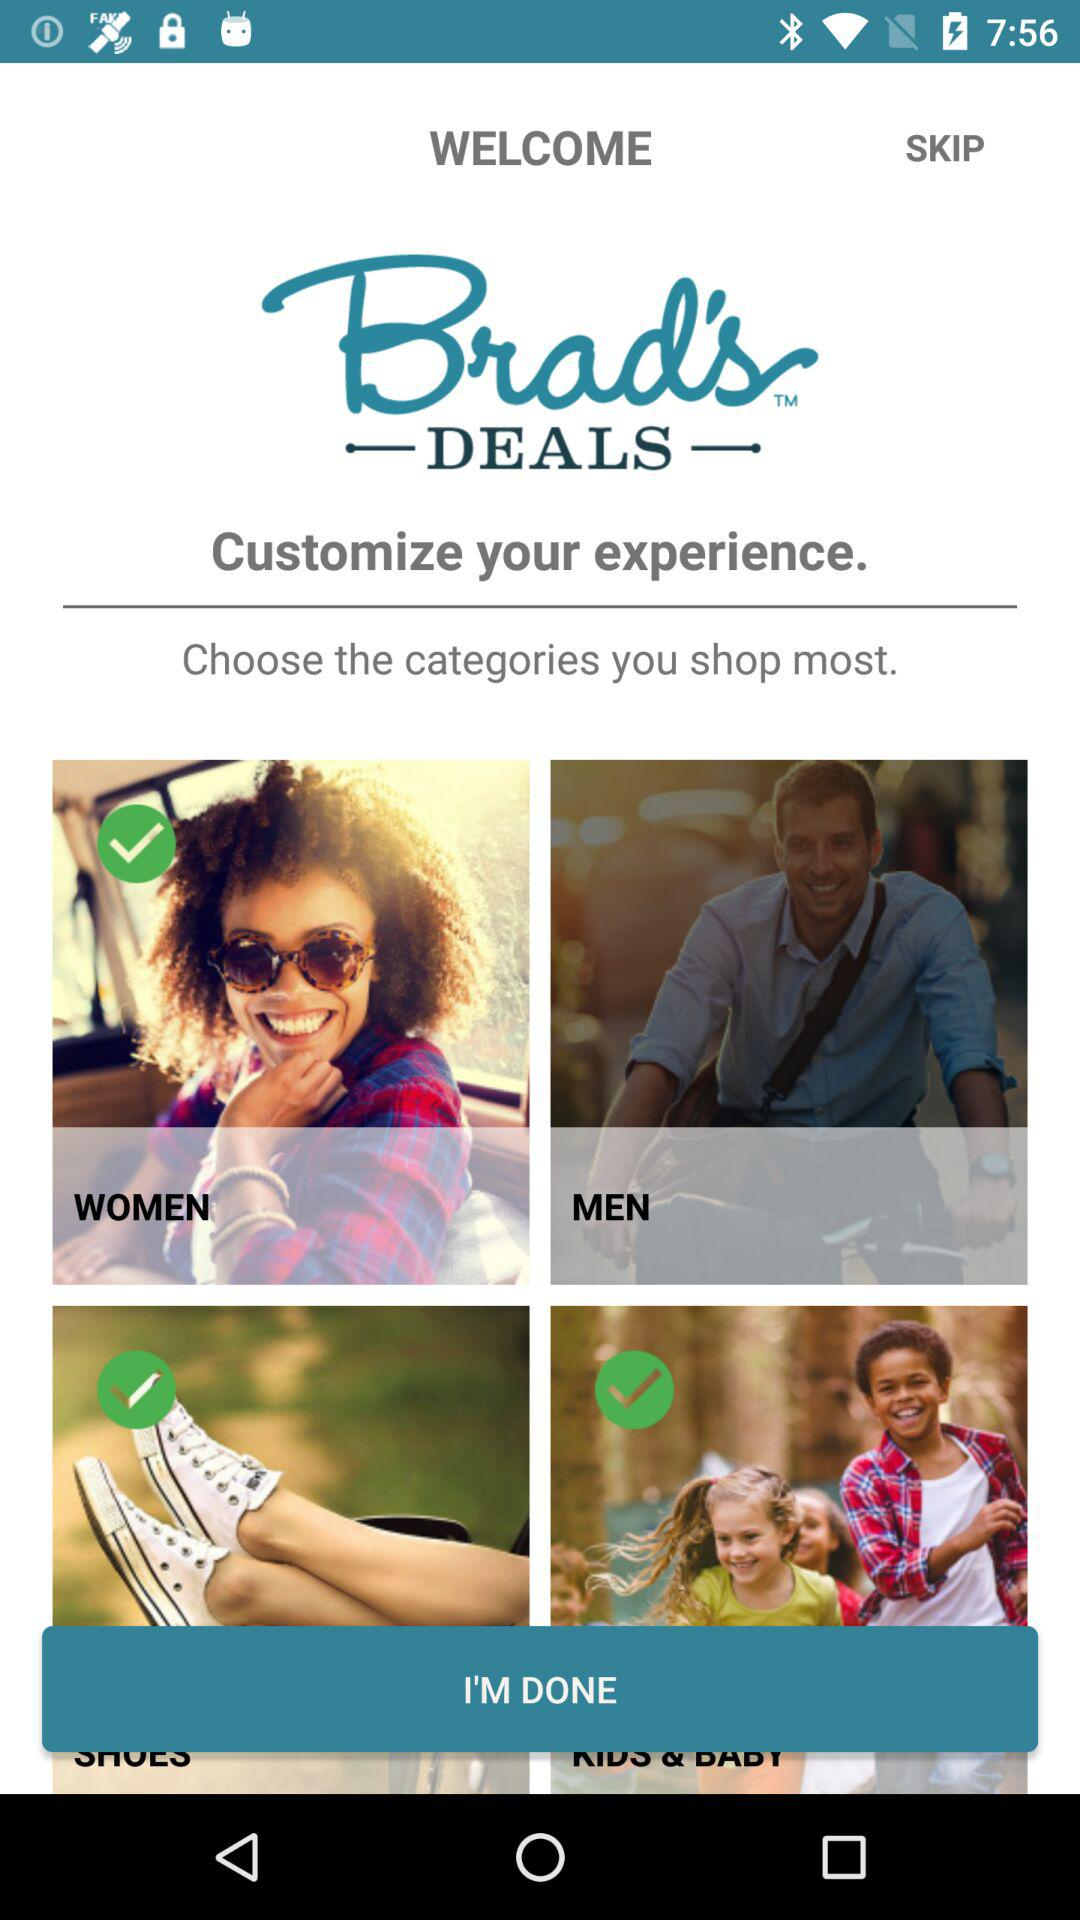What are the different categories available to choose from for shopping? The different categories are "WOMEN" and "MEN". 